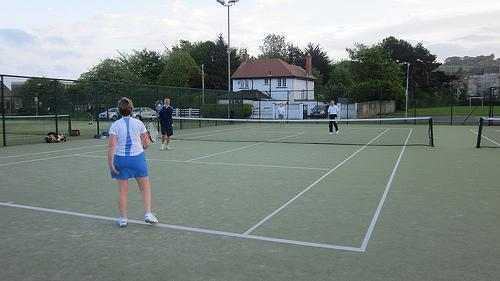Question: who is wearing the white and blue outfit?
Choices:
A. The woman.
B. The man.
C. The boy.
D. The girl.
Answer with the letter. Answer: A Question: what sport is being played?
Choices:
A. Basketball.
B. Baseball.
C. Football.
D. Tennis.
Answer with the letter. Answer: D Question: what color is the court?
Choices:
A. Red.
B. Green.
C. Brown.
D. Yellow.
Answer with the letter. Answer: B Question: where was this picture taken?
Choices:
A. Basketball court.
B. Baseball field.
C. Tennis court.
D. Football field.
Answer with the letter. Answer: C Question: how many people are playing?
Choices:
A. Two.
B. Six.
C. Four.
D. Twelve.
Answer with the letter. Answer: C 